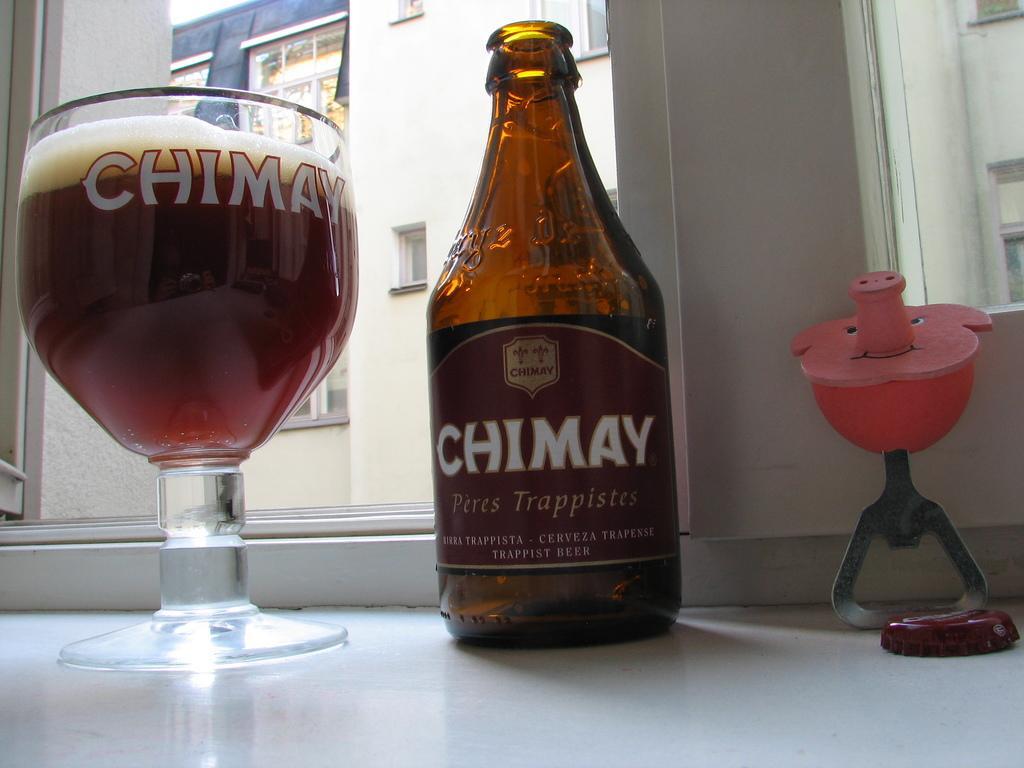Could you give a brief overview of what you see in this image? As we can see in the image there is a building, window, glass and bottle on table. 